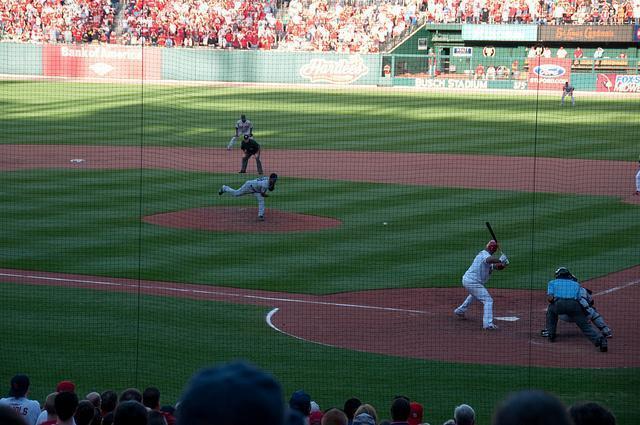How many players are you able to see on the field?
Give a very brief answer. 5. How many people are in the photo?
Give a very brief answer. 2. 